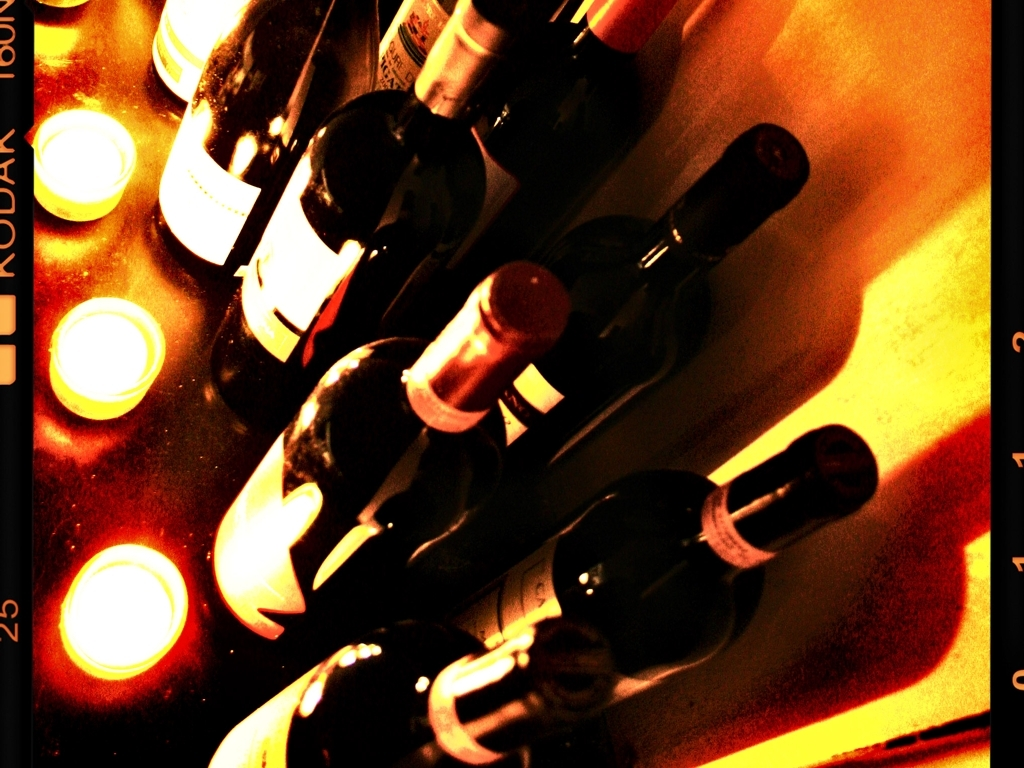Could you describe the setting or possible location where this photo was taken? Based on the contents of the image, which include multiple wine bottles, likely in a rack, and ambient lighting, this photo could have been taken at a wine cellar, a bar, or a private collection within someone's home. The setting is designed to highlight the wine selection, making it an important feature of the place. What kind of establishment or home would display their wine like this? An establishment with a focus on wine, such as a wine bar, restaurant with a strong wine selection, or a boutique wine shop, would likely display their wine in this manner. For a private home, this could indicate a wine enthusiast or collector who appreciates displaying their collection prominently and with aesthetic considerations in mind. 